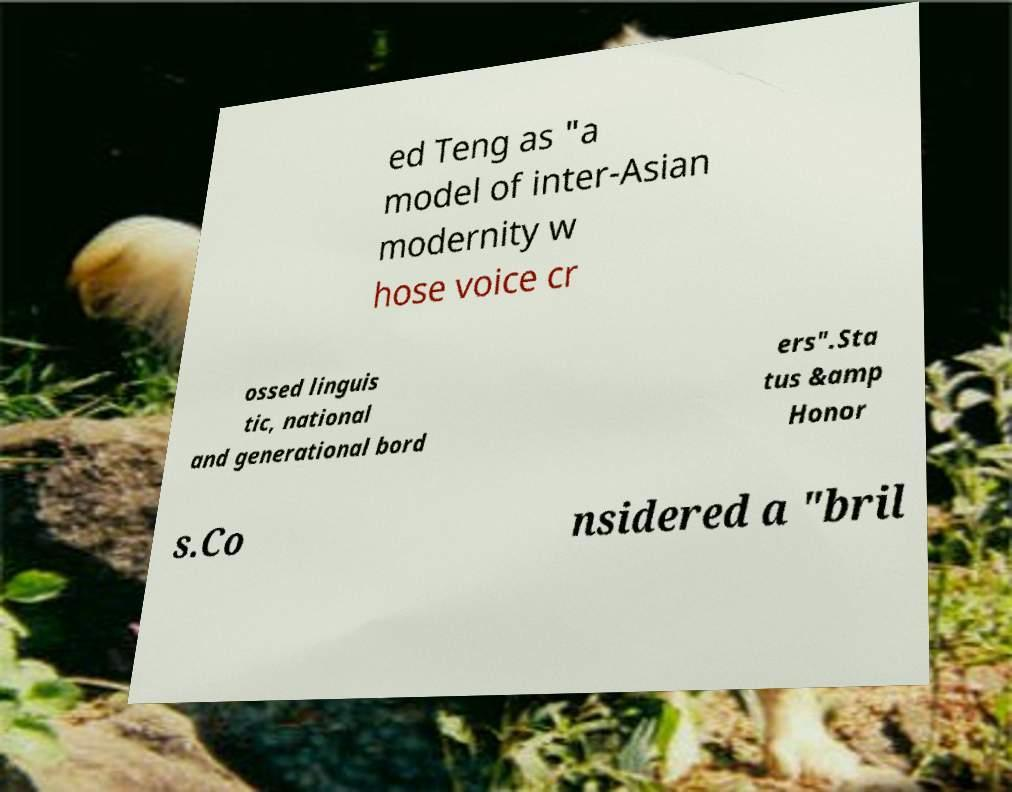Please identify and transcribe the text found in this image. ed Teng as "a model of inter-Asian modernity w hose voice cr ossed linguis tic, national and generational bord ers".Sta tus &amp Honor s.Co nsidered a "bril 